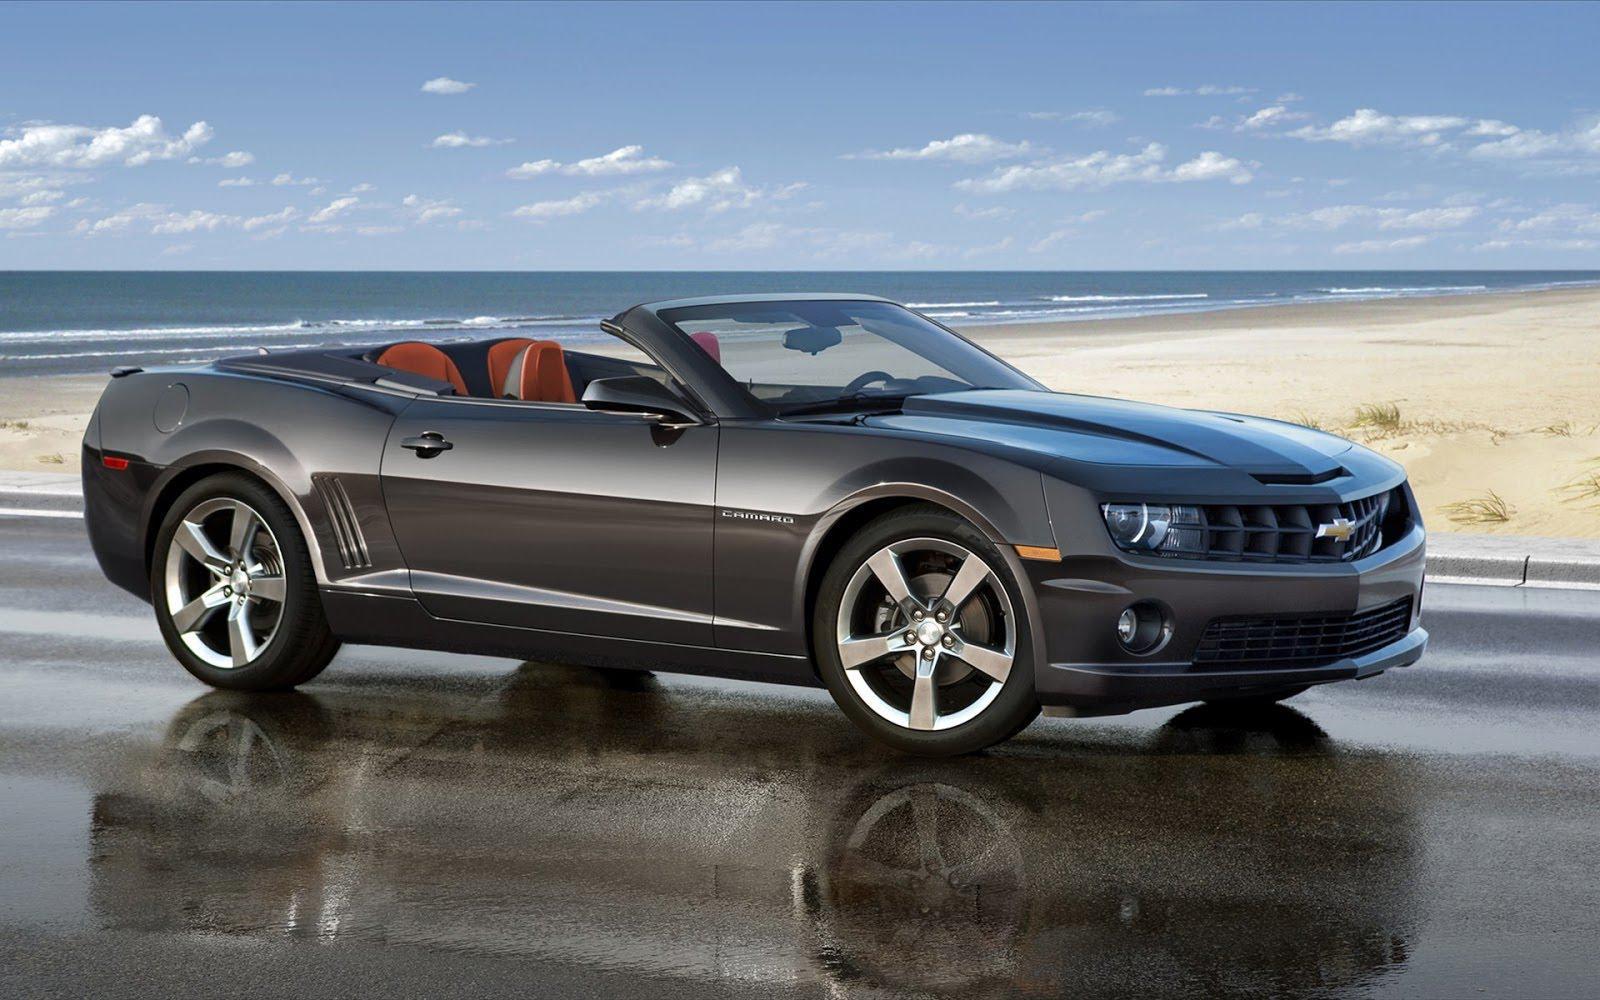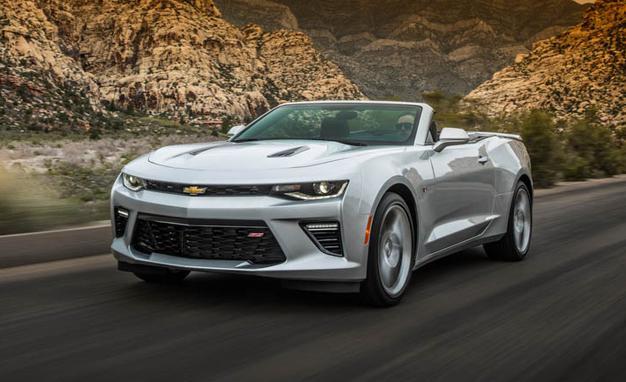The first image is the image on the left, the second image is the image on the right. Examine the images to the left and right. Is the description "The cars in both images are parked indoors." accurate? Answer yes or no. No. The first image is the image on the left, the second image is the image on the right. Evaluate the accuracy of this statement regarding the images: "An image shows an angled white convertible with top down in an outdoor scene.". Is it true? Answer yes or no. Yes. 